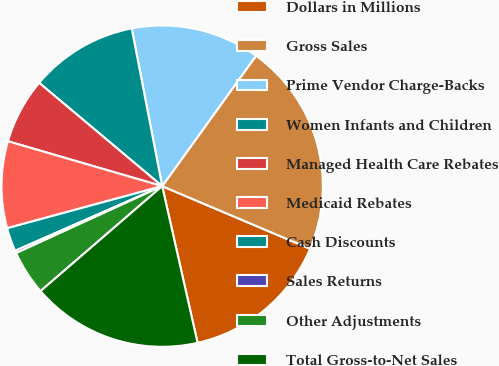<chart> <loc_0><loc_0><loc_500><loc_500><pie_chart><fcel>Dollars in Millions<fcel>Gross Sales<fcel>Prime Vendor Charge-Backs<fcel>Women Infants and Children<fcel>Managed Health Care Rebates<fcel>Medicaid Rebates<fcel>Cash Discounts<fcel>Sales Returns<fcel>Other Adjustments<fcel>Total Gross-to-Net Sales<nl><fcel>15.09%<fcel>21.45%<fcel>12.97%<fcel>10.85%<fcel>6.61%<fcel>8.73%<fcel>2.37%<fcel>0.25%<fcel>4.49%<fcel>17.21%<nl></chart> 